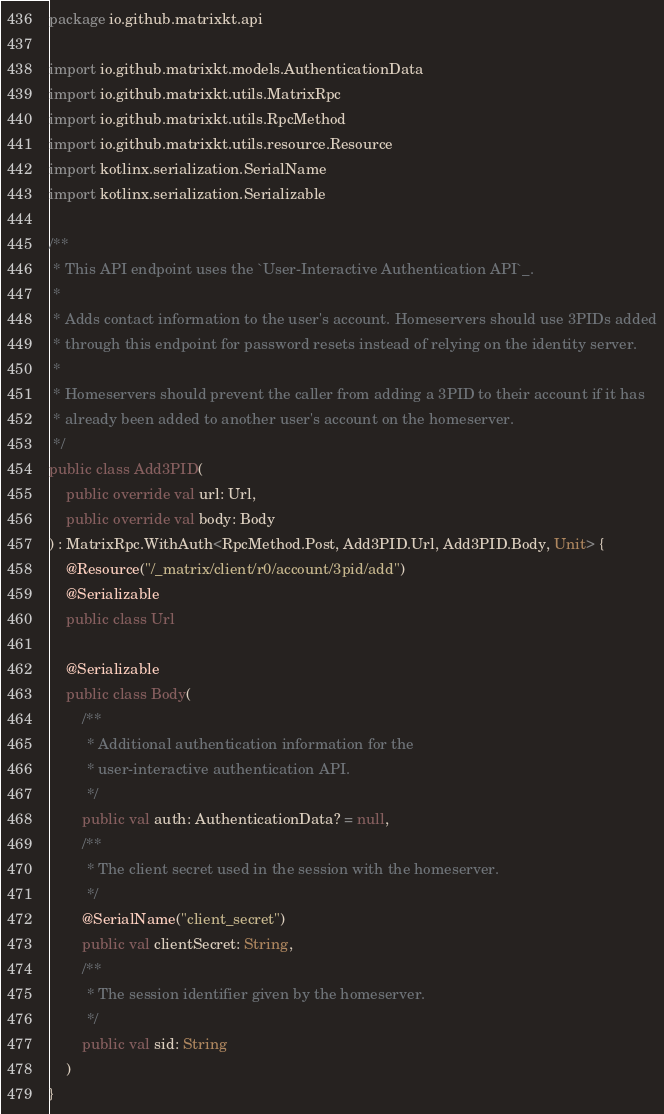<code> <loc_0><loc_0><loc_500><loc_500><_Kotlin_>package io.github.matrixkt.api

import io.github.matrixkt.models.AuthenticationData
import io.github.matrixkt.utils.MatrixRpc
import io.github.matrixkt.utils.RpcMethod
import io.github.matrixkt.utils.resource.Resource
import kotlinx.serialization.SerialName
import kotlinx.serialization.Serializable

/**
 * This API endpoint uses the `User-Interactive Authentication API`_.
 *
 * Adds contact information to the user's account. Homeservers should use 3PIDs added
 * through this endpoint for password resets instead of relying on the identity server.
 *
 * Homeservers should prevent the caller from adding a 3PID to their account if it has
 * already been added to another user's account on the homeserver.
 */
public class Add3PID(
    public override val url: Url,
    public override val body: Body
) : MatrixRpc.WithAuth<RpcMethod.Post, Add3PID.Url, Add3PID.Body, Unit> {
    @Resource("/_matrix/client/r0/account/3pid/add")
    @Serializable
    public class Url

    @Serializable
    public class Body(
        /**
         * Additional authentication information for the
         * user-interactive authentication API.
         */
        public val auth: AuthenticationData? = null,
        /**
         * The client secret used in the session with the homeserver.
         */
        @SerialName("client_secret")
        public val clientSecret: String,
        /**
         * The session identifier given by the homeserver.
         */
        public val sid: String
    )
}
</code> 